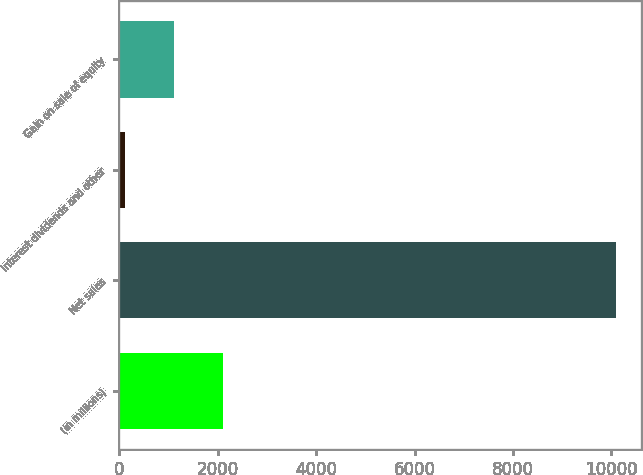Convert chart. <chart><loc_0><loc_0><loc_500><loc_500><bar_chart><fcel>(in millions)<fcel>Net sales<fcel>Interest dividends and other<fcel>Gain on sale of equity<nl><fcel>2102.8<fcel>10090<fcel>106<fcel>1104.4<nl></chart> 